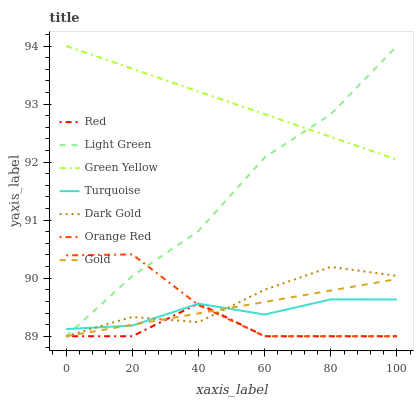Does Red have the minimum area under the curve?
Answer yes or no. Yes. Does Green Yellow have the maximum area under the curve?
Answer yes or no. Yes. Does Gold have the minimum area under the curve?
Answer yes or no. No. Does Gold have the maximum area under the curve?
Answer yes or no. No. Is Green Yellow the smoothest?
Answer yes or no. Yes. Is Red the roughest?
Answer yes or no. Yes. Is Gold the smoothest?
Answer yes or no. No. Is Gold the roughest?
Answer yes or no. No. Does Gold have the lowest value?
Answer yes or no. Yes. Does Green Yellow have the lowest value?
Answer yes or no. No. Does Green Yellow have the highest value?
Answer yes or no. Yes. Does Gold have the highest value?
Answer yes or no. No. Is Orange Red less than Green Yellow?
Answer yes or no. Yes. Is Green Yellow greater than Red?
Answer yes or no. Yes. Does Turquoise intersect Red?
Answer yes or no. Yes. Is Turquoise less than Red?
Answer yes or no. No. Is Turquoise greater than Red?
Answer yes or no. No. Does Orange Red intersect Green Yellow?
Answer yes or no. No. 